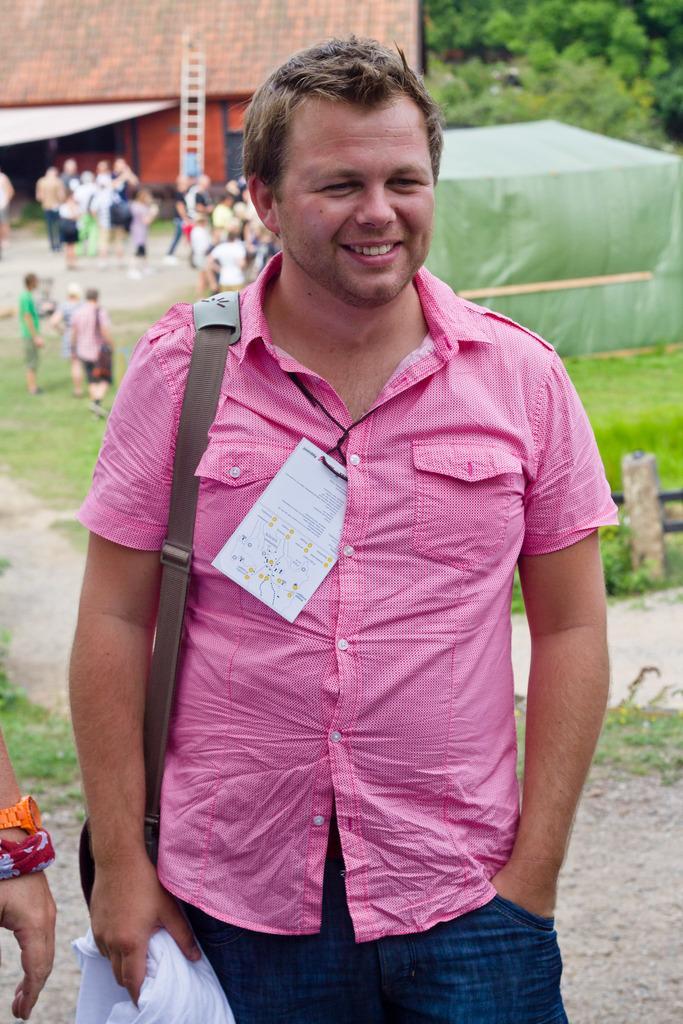Could you give a brief overview of what you see in this image? In this image we can see a man standing on the ground and wearing a id card in his neck. The man is wearing a bag on his shoulder and holding a cloth in one of his hands. In the background we can see trees, building, ladder, crowd, grass and a concrete pole. 